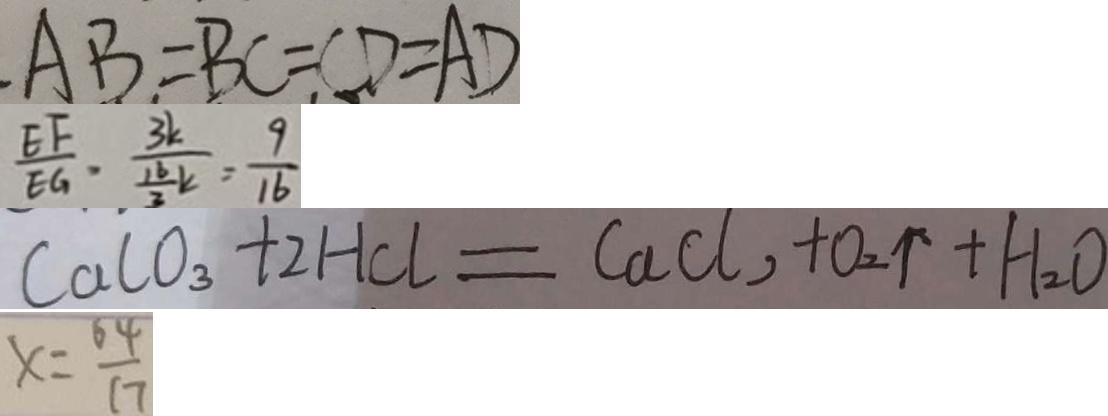Convert formula to latex. <formula><loc_0><loc_0><loc_500><loc_500>A B = B C = C D = A D 
 \frac { E F } { E G } , \frac { 3 k } { \frac { 1 6 } { 3 } k } = \frac { 9 } { 1 6 } 
 C a C O _ { 3 } + 2 H C l = C a C l , + O _ { 2 } \uparrow + H _ { 2 } O 
 x = \frac { 6 4 } { 1 7 }</formula> 